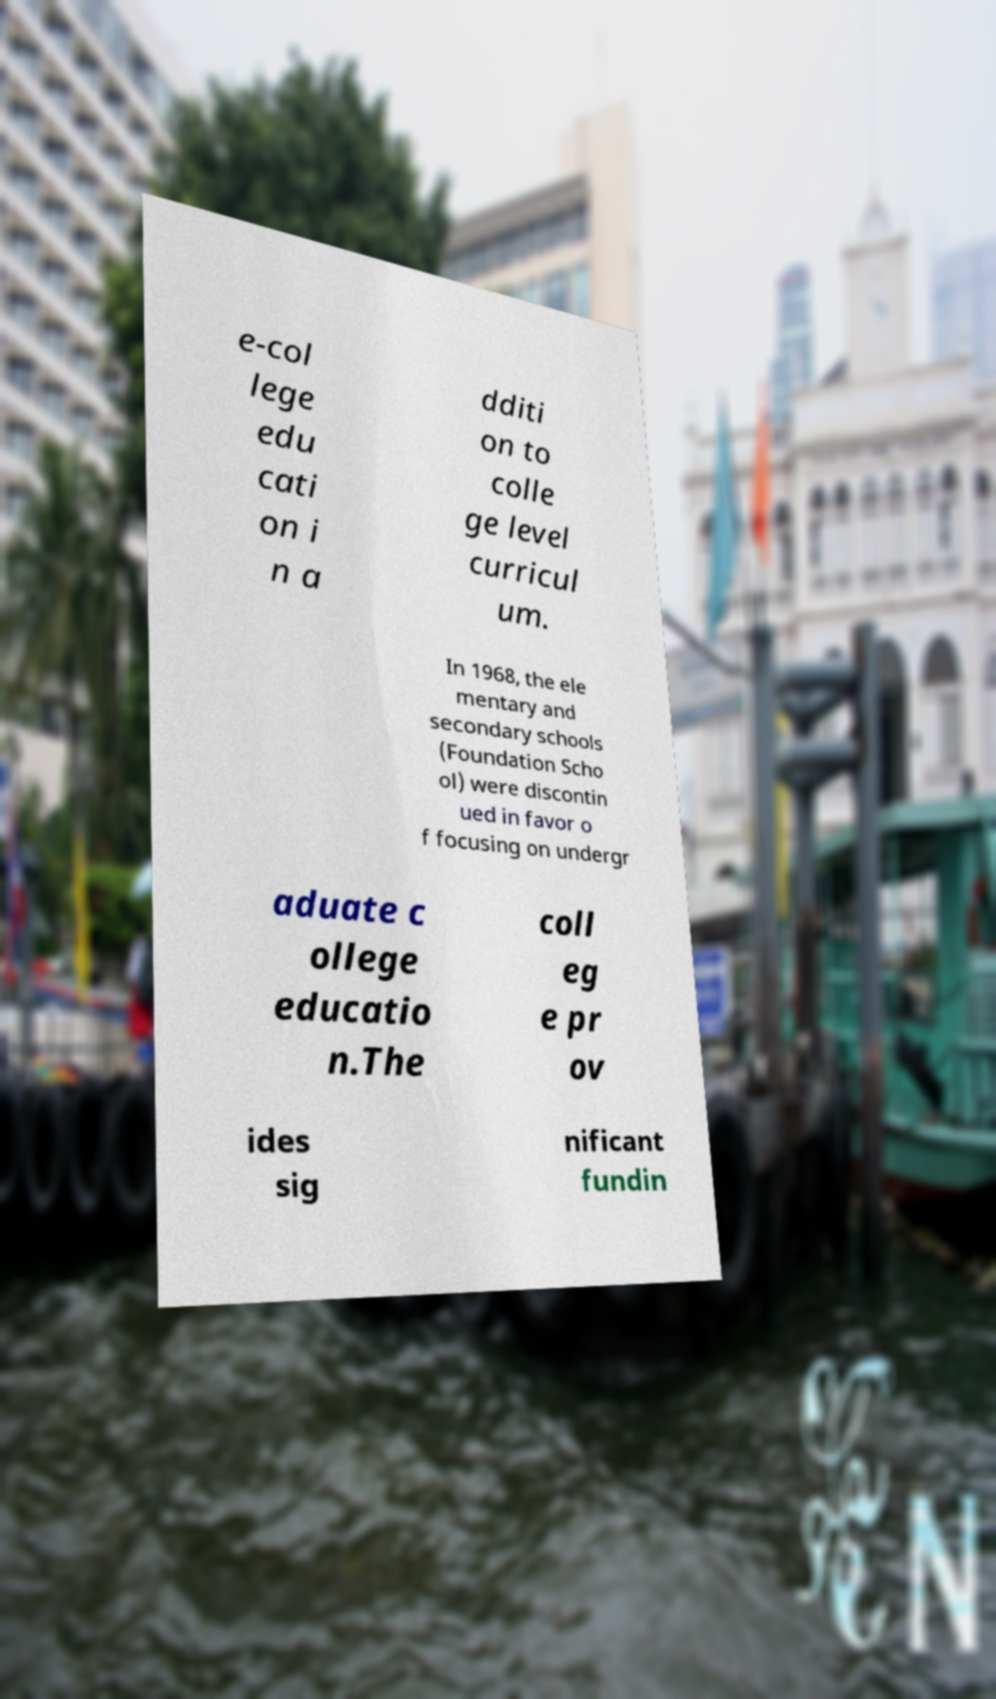For documentation purposes, I need the text within this image transcribed. Could you provide that? e-col lege edu cati on i n a dditi on to colle ge level curricul um. In 1968, the ele mentary and secondary schools (Foundation Scho ol) were discontin ued in favor o f focusing on undergr aduate c ollege educatio n.The coll eg e pr ov ides sig nificant fundin 